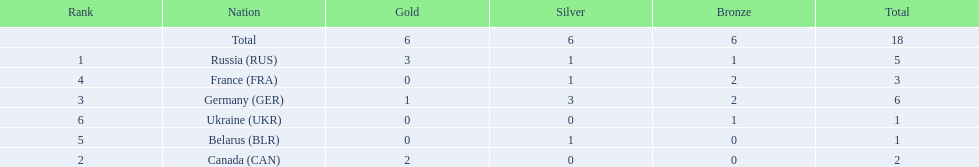What are all the countries in the 1994 winter olympics biathlon? Russia (RUS), Canada (CAN), Germany (GER), France (FRA), Belarus (BLR), Ukraine (UKR). Which of these received at least one gold medal? Russia (RUS), Canada (CAN), Germany (GER). Which of these received no silver or bronze medals? Canada (CAN). 